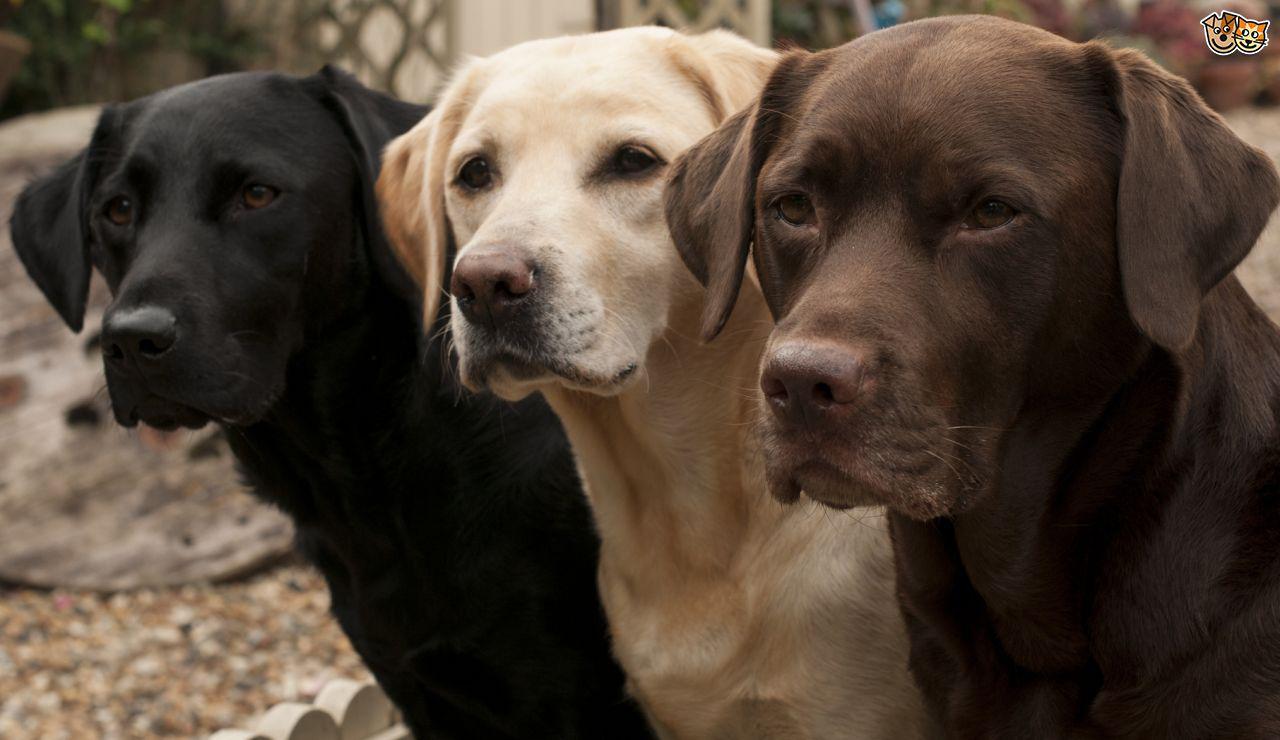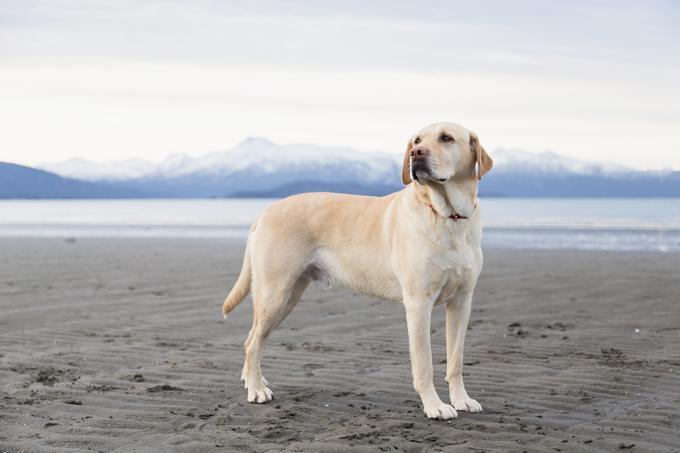The first image is the image on the left, the second image is the image on the right. Assess this claim about the two images: "In 1 of the images, a dog is standing on grass.". Correct or not? Answer yes or no. No. 